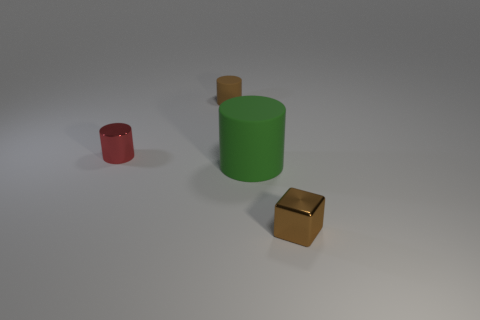Is there any other thing of the same color as the tiny metallic block?
Offer a very short reply. Yes. How many metal objects are tiny blocks or tiny objects?
Your answer should be compact. 2. Is the color of the big rubber thing the same as the block?
Provide a succinct answer. No. Are there more rubber things on the right side of the green matte object than cyan cylinders?
Make the answer very short. No. How many other objects are the same material as the red cylinder?
Offer a terse response. 1. How many small objects are either matte objects or brown cubes?
Ensure brevity in your answer.  2. Are the small red cylinder and the block made of the same material?
Your answer should be very brief. Yes. There is a small metallic thing behind the small brown shiny cube; what number of brown shiny objects are in front of it?
Provide a short and direct response. 1. Is there a tiny gray metallic thing that has the same shape as the small matte object?
Provide a succinct answer. No. Does the tiny brown object in front of the big thing have the same shape as the brown thing behind the large cylinder?
Offer a very short reply. No. 